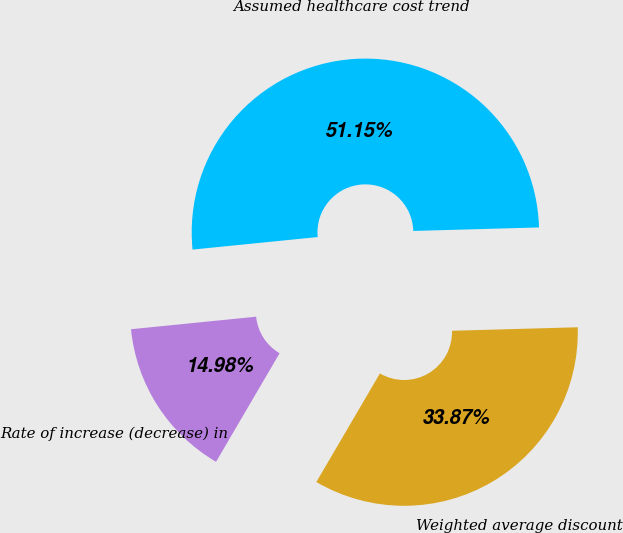Convert chart. <chart><loc_0><loc_0><loc_500><loc_500><pie_chart><fcel>Weighted average discount<fcel>Rate of increase (decrease) in<fcel>Assumed healthcare cost trend<nl><fcel>33.87%<fcel>14.98%<fcel>51.14%<nl></chart> 